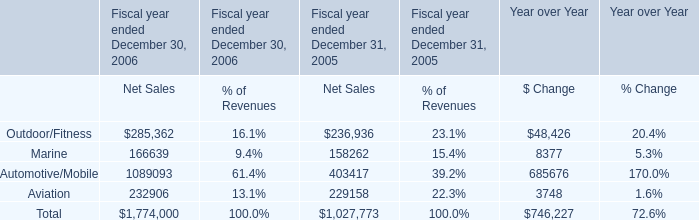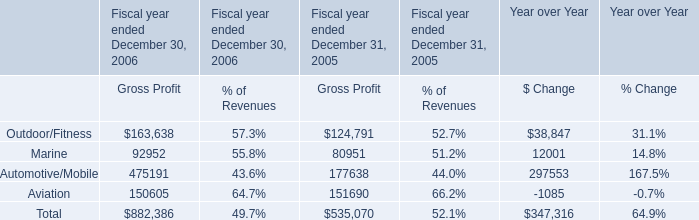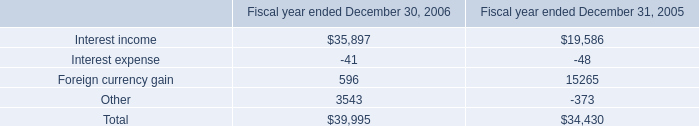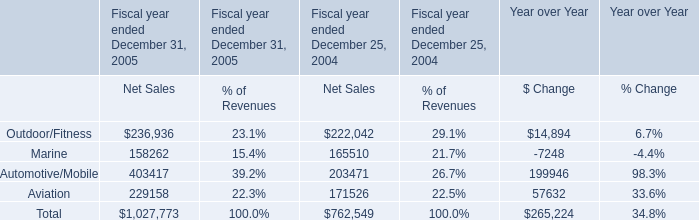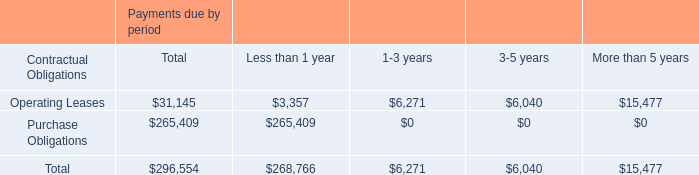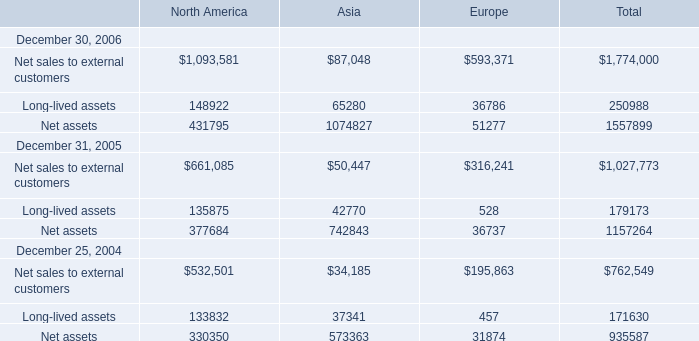what's the total amount of Net assets December 31, 2005 of Europe, Outdoor/Fitness of Fiscal year ended December 30, 2006 Gross Profit, and Total of Fiscal year ended December 30, 2006 Gross Profit ? 
Computations: ((36737.0 + 163638.0) + 882386.0)
Answer: 1082761.0. 